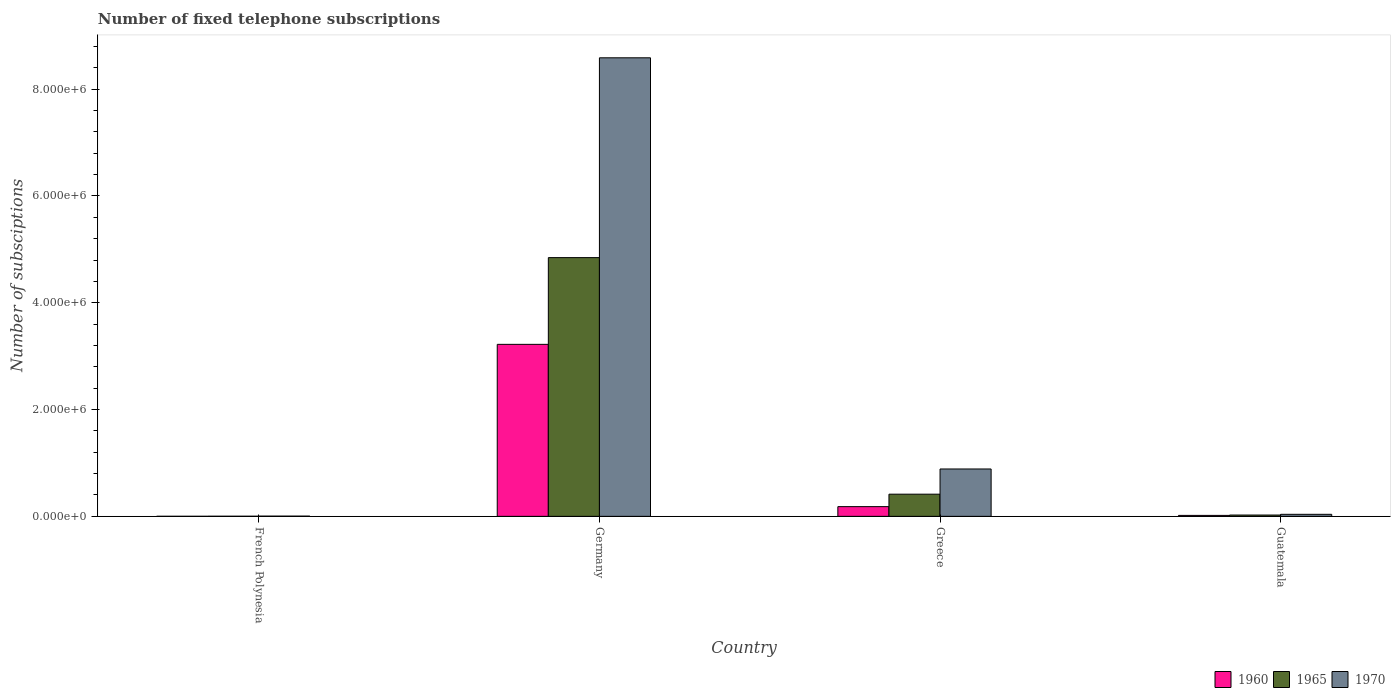How many different coloured bars are there?
Ensure brevity in your answer.  3. Are the number of bars per tick equal to the number of legend labels?
Make the answer very short. Yes. Are the number of bars on each tick of the X-axis equal?
Your response must be concise. Yes. How many bars are there on the 1st tick from the right?
Your answer should be compact. 3. What is the number of fixed telephone subscriptions in 1960 in Greece?
Provide a short and direct response. 1.82e+05. Across all countries, what is the maximum number of fixed telephone subscriptions in 1965?
Make the answer very short. 4.84e+06. Across all countries, what is the minimum number of fixed telephone subscriptions in 1970?
Keep it short and to the point. 4000. In which country was the number of fixed telephone subscriptions in 1960 maximum?
Give a very brief answer. Germany. In which country was the number of fixed telephone subscriptions in 1970 minimum?
Ensure brevity in your answer.  French Polynesia. What is the total number of fixed telephone subscriptions in 1965 in the graph?
Provide a short and direct response. 5.29e+06. What is the difference between the number of fixed telephone subscriptions in 1965 in Germany and that in Greece?
Offer a very short reply. 4.43e+06. What is the difference between the number of fixed telephone subscriptions in 1965 in Guatemala and the number of fixed telephone subscriptions in 1970 in French Polynesia?
Provide a short and direct response. 2.03e+04. What is the average number of fixed telephone subscriptions in 1960 per country?
Your answer should be very brief. 8.55e+05. What is the difference between the number of fixed telephone subscriptions of/in 1965 and number of fixed telephone subscriptions of/in 1970 in Germany?
Offer a terse response. -3.74e+06. What is the ratio of the number of fixed telephone subscriptions in 1970 in Germany to that in Greece?
Your answer should be very brief. 9.68. Is the difference between the number of fixed telephone subscriptions in 1965 in Greece and Guatemala greater than the difference between the number of fixed telephone subscriptions in 1970 in Greece and Guatemala?
Give a very brief answer. No. What is the difference between the highest and the second highest number of fixed telephone subscriptions in 1965?
Give a very brief answer. 4.43e+06. What is the difference between the highest and the lowest number of fixed telephone subscriptions in 1960?
Make the answer very short. 3.22e+06. What does the 3rd bar from the right in Greece represents?
Keep it short and to the point. 1960. Is it the case that in every country, the sum of the number of fixed telephone subscriptions in 1960 and number of fixed telephone subscriptions in 1970 is greater than the number of fixed telephone subscriptions in 1965?
Give a very brief answer. Yes. Are all the bars in the graph horizontal?
Keep it short and to the point. No. How many countries are there in the graph?
Your answer should be compact. 4. Does the graph contain any zero values?
Offer a very short reply. No. How are the legend labels stacked?
Your answer should be very brief. Horizontal. What is the title of the graph?
Your answer should be very brief. Number of fixed telephone subscriptions. Does "1997" appear as one of the legend labels in the graph?
Offer a terse response. No. What is the label or title of the X-axis?
Your response must be concise. Country. What is the label or title of the Y-axis?
Your answer should be very brief. Number of subsciptions. What is the Number of subsciptions of 1960 in French Polynesia?
Your answer should be compact. 827. What is the Number of subsciptions of 1965 in French Polynesia?
Your answer should be compact. 1900. What is the Number of subsciptions in 1970 in French Polynesia?
Offer a terse response. 4000. What is the Number of subsciptions in 1960 in Germany?
Offer a terse response. 3.22e+06. What is the Number of subsciptions in 1965 in Germany?
Ensure brevity in your answer.  4.84e+06. What is the Number of subsciptions in 1970 in Germany?
Your response must be concise. 8.59e+06. What is the Number of subsciptions of 1960 in Greece?
Offer a very short reply. 1.82e+05. What is the Number of subsciptions of 1965 in Greece?
Provide a short and direct response. 4.15e+05. What is the Number of subsciptions in 1970 in Greece?
Make the answer very short. 8.87e+05. What is the Number of subsciptions in 1960 in Guatemala?
Give a very brief answer. 1.78e+04. What is the Number of subsciptions in 1965 in Guatemala?
Your response must be concise. 2.43e+04. What is the Number of subsciptions in 1970 in Guatemala?
Your answer should be compact. 3.79e+04. Across all countries, what is the maximum Number of subsciptions of 1960?
Your answer should be very brief. 3.22e+06. Across all countries, what is the maximum Number of subsciptions of 1965?
Provide a succinct answer. 4.84e+06. Across all countries, what is the maximum Number of subsciptions of 1970?
Provide a succinct answer. 8.59e+06. Across all countries, what is the minimum Number of subsciptions in 1960?
Make the answer very short. 827. Across all countries, what is the minimum Number of subsciptions of 1965?
Your response must be concise. 1900. Across all countries, what is the minimum Number of subsciptions in 1970?
Keep it short and to the point. 4000. What is the total Number of subsciptions in 1960 in the graph?
Provide a succinct answer. 3.42e+06. What is the total Number of subsciptions in 1965 in the graph?
Your response must be concise. 5.29e+06. What is the total Number of subsciptions in 1970 in the graph?
Make the answer very short. 9.52e+06. What is the difference between the Number of subsciptions in 1960 in French Polynesia and that in Germany?
Give a very brief answer. -3.22e+06. What is the difference between the Number of subsciptions in 1965 in French Polynesia and that in Germany?
Offer a terse response. -4.84e+06. What is the difference between the Number of subsciptions in 1970 in French Polynesia and that in Germany?
Make the answer very short. -8.58e+06. What is the difference between the Number of subsciptions in 1960 in French Polynesia and that in Greece?
Your response must be concise. -1.81e+05. What is the difference between the Number of subsciptions in 1965 in French Polynesia and that in Greece?
Give a very brief answer. -4.13e+05. What is the difference between the Number of subsciptions in 1970 in French Polynesia and that in Greece?
Provide a succinct answer. -8.83e+05. What is the difference between the Number of subsciptions of 1960 in French Polynesia and that in Guatemala?
Offer a terse response. -1.70e+04. What is the difference between the Number of subsciptions of 1965 in French Polynesia and that in Guatemala?
Give a very brief answer. -2.24e+04. What is the difference between the Number of subsciptions of 1970 in French Polynesia and that in Guatemala?
Ensure brevity in your answer.  -3.39e+04. What is the difference between the Number of subsciptions of 1960 in Germany and that in Greece?
Give a very brief answer. 3.04e+06. What is the difference between the Number of subsciptions in 1965 in Germany and that in Greece?
Offer a terse response. 4.43e+06. What is the difference between the Number of subsciptions in 1970 in Germany and that in Greece?
Offer a very short reply. 7.70e+06. What is the difference between the Number of subsciptions in 1960 in Germany and that in Guatemala?
Give a very brief answer. 3.20e+06. What is the difference between the Number of subsciptions of 1965 in Germany and that in Guatemala?
Your answer should be compact. 4.82e+06. What is the difference between the Number of subsciptions in 1970 in Germany and that in Guatemala?
Make the answer very short. 8.55e+06. What is the difference between the Number of subsciptions in 1960 in Greece and that in Guatemala?
Offer a terse response. 1.64e+05. What is the difference between the Number of subsciptions of 1965 in Greece and that in Guatemala?
Give a very brief answer. 3.91e+05. What is the difference between the Number of subsciptions in 1970 in Greece and that in Guatemala?
Your answer should be very brief. 8.49e+05. What is the difference between the Number of subsciptions in 1960 in French Polynesia and the Number of subsciptions in 1965 in Germany?
Provide a short and direct response. -4.84e+06. What is the difference between the Number of subsciptions of 1960 in French Polynesia and the Number of subsciptions of 1970 in Germany?
Provide a short and direct response. -8.59e+06. What is the difference between the Number of subsciptions of 1965 in French Polynesia and the Number of subsciptions of 1970 in Germany?
Provide a succinct answer. -8.59e+06. What is the difference between the Number of subsciptions in 1960 in French Polynesia and the Number of subsciptions in 1965 in Greece?
Your answer should be compact. -4.14e+05. What is the difference between the Number of subsciptions of 1960 in French Polynesia and the Number of subsciptions of 1970 in Greece?
Ensure brevity in your answer.  -8.86e+05. What is the difference between the Number of subsciptions of 1965 in French Polynesia and the Number of subsciptions of 1970 in Greece?
Your answer should be compact. -8.85e+05. What is the difference between the Number of subsciptions of 1960 in French Polynesia and the Number of subsciptions of 1965 in Guatemala?
Your response must be concise. -2.35e+04. What is the difference between the Number of subsciptions in 1960 in French Polynesia and the Number of subsciptions in 1970 in Guatemala?
Ensure brevity in your answer.  -3.70e+04. What is the difference between the Number of subsciptions of 1965 in French Polynesia and the Number of subsciptions of 1970 in Guatemala?
Ensure brevity in your answer.  -3.60e+04. What is the difference between the Number of subsciptions of 1960 in Germany and the Number of subsciptions of 1965 in Greece?
Make the answer very short. 2.81e+06. What is the difference between the Number of subsciptions of 1960 in Germany and the Number of subsciptions of 1970 in Greece?
Offer a terse response. 2.33e+06. What is the difference between the Number of subsciptions of 1965 in Germany and the Number of subsciptions of 1970 in Greece?
Your answer should be compact. 3.96e+06. What is the difference between the Number of subsciptions in 1960 in Germany and the Number of subsciptions in 1965 in Guatemala?
Give a very brief answer. 3.20e+06. What is the difference between the Number of subsciptions in 1960 in Germany and the Number of subsciptions in 1970 in Guatemala?
Ensure brevity in your answer.  3.18e+06. What is the difference between the Number of subsciptions of 1965 in Germany and the Number of subsciptions of 1970 in Guatemala?
Your answer should be compact. 4.81e+06. What is the difference between the Number of subsciptions of 1960 in Greece and the Number of subsciptions of 1965 in Guatemala?
Ensure brevity in your answer.  1.57e+05. What is the difference between the Number of subsciptions in 1960 in Greece and the Number of subsciptions in 1970 in Guatemala?
Give a very brief answer. 1.44e+05. What is the difference between the Number of subsciptions in 1965 in Greece and the Number of subsciptions in 1970 in Guatemala?
Your answer should be compact. 3.77e+05. What is the average Number of subsciptions of 1960 per country?
Offer a terse response. 8.55e+05. What is the average Number of subsciptions of 1965 per country?
Offer a terse response. 1.32e+06. What is the average Number of subsciptions in 1970 per country?
Offer a terse response. 2.38e+06. What is the difference between the Number of subsciptions in 1960 and Number of subsciptions in 1965 in French Polynesia?
Offer a terse response. -1073. What is the difference between the Number of subsciptions of 1960 and Number of subsciptions of 1970 in French Polynesia?
Ensure brevity in your answer.  -3173. What is the difference between the Number of subsciptions of 1965 and Number of subsciptions of 1970 in French Polynesia?
Your answer should be very brief. -2100. What is the difference between the Number of subsciptions in 1960 and Number of subsciptions in 1965 in Germany?
Offer a terse response. -1.62e+06. What is the difference between the Number of subsciptions of 1960 and Number of subsciptions of 1970 in Germany?
Your answer should be compact. -5.37e+06. What is the difference between the Number of subsciptions in 1965 and Number of subsciptions in 1970 in Germany?
Provide a short and direct response. -3.74e+06. What is the difference between the Number of subsciptions of 1960 and Number of subsciptions of 1965 in Greece?
Your answer should be very brief. -2.33e+05. What is the difference between the Number of subsciptions in 1960 and Number of subsciptions in 1970 in Greece?
Ensure brevity in your answer.  -7.05e+05. What is the difference between the Number of subsciptions of 1965 and Number of subsciptions of 1970 in Greece?
Your answer should be compact. -4.72e+05. What is the difference between the Number of subsciptions in 1960 and Number of subsciptions in 1965 in Guatemala?
Make the answer very short. -6485. What is the difference between the Number of subsciptions of 1960 and Number of subsciptions of 1970 in Guatemala?
Ensure brevity in your answer.  -2.00e+04. What is the difference between the Number of subsciptions of 1965 and Number of subsciptions of 1970 in Guatemala?
Keep it short and to the point. -1.36e+04. What is the ratio of the Number of subsciptions of 1960 in French Polynesia to that in Greece?
Your response must be concise. 0. What is the ratio of the Number of subsciptions in 1965 in French Polynesia to that in Greece?
Keep it short and to the point. 0. What is the ratio of the Number of subsciptions of 1970 in French Polynesia to that in Greece?
Your answer should be very brief. 0. What is the ratio of the Number of subsciptions in 1960 in French Polynesia to that in Guatemala?
Your answer should be compact. 0.05. What is the ratio of the Number of subsciptions of 1965 in French Polynesia to that in Guatemala?
Offer a very short reply. 0.08. What is the ratio of the Number of subsciptions in 1970 in French Polynesia to that in Guatemala?
Give a very brief answer. 0.11. What is the ratio of the Number of subsciptions in 1960 in Germany to that in Greece?
Your answer should be compact. 17.72. What is the ratio of the Number of subsciptions in 1965 in Germany to that in Greece?
Your answer should be very brief. 11.67. What is the ratio of the Number of subsciptions of 1970 in Germany to that in Greece?
Keep it short and to the point. 9.68. What is the ratio of the Number of subsciptions of 1960 in Germany to that in Guatemala?
Provide a short and direct response. 180.74. What is the ratio of the Number of subsciptions in 1965 in Germany to that in Guatemala?
Provide a succinct answer. 199.33. What is the ratio of the Number of subsciptions in 1970 in Germany to that in Guatemala?
Provide a short and direct response. 226.74. What is the ratio of the Number of subsciptions in 1960 in Greece to that in Guatemala?
Your response must be concise. 10.2. What is the ratio of the Number of subsciptions of 1965 in Greece to that in Guatemala?
Offer a terse response. 17.07. What is the ratio of the Number of subsciptions in 1970 in Greece to that in Guatemala?
Ensure brevity in your answer.  23.42. What is the difference between the highest and the second highest Number of subsciptions in 1960?
Your answer should be compact. 3.04e+06. What is the difference between the highest and the second highest Number of subsciptions of 1965?
Offer a terse response. 4.43e+06. What is the difference between the highest and the second highest Number of subsciptions of 1970?
Provide a short and direct response. 7.70e+06. What is the difference between the highest and the lowest Number of subsciptions in 1960?
Ensure brevity in your answer.  3.22e+06. What is the difference between the highest and the lowest Number of subsciptions in 1965?
Provide a succinct answer. 4.84e+06. What is the difference between the highest and the lowest Number of subsciptions of 1970?
Give a very brief answer. 8.58e+06. 